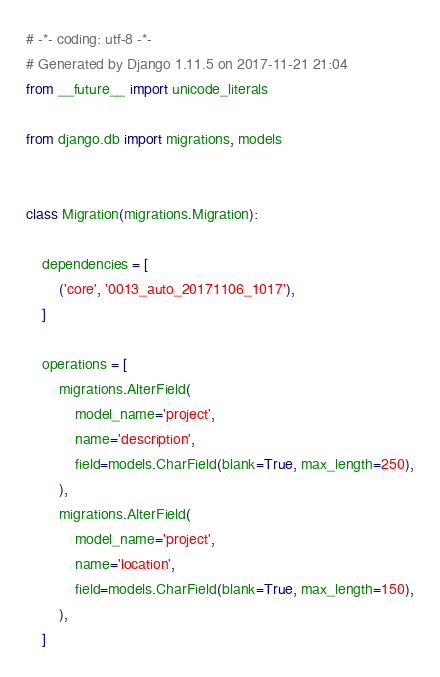<code> <loc_0><loc_0><loc_500><loc_500><_Python_># -*- coding: utf-8 -*-
# Generated by Django 1.11.5 on 2017-11-21 21:04
from __future__ import unicode_literals

from django.db import migrations, models


class Migration(migrations.Migration):

    dependencies = [
        ('core', '0013_auto_20171106_1017'),
    ]

    operations = [
        migrations.AlterField(
            model_name='project',
            name='description',
            field=models.CharField(blank=True, max_length=250),
        ),
        migrations.AlterField(
            model_name='project',
            name='location',
            field=models.CharField(blank=True, max_length=150),
        ),
    ]
</code> 